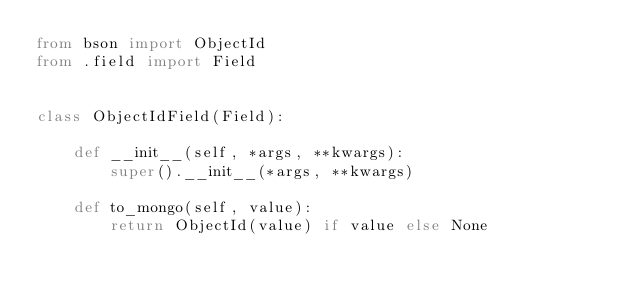<code> <loc_0><loc_0><loc_500><loc_500><_Python_>from bson import ObjectId
from .field import Field


class ObjectIdField(Field):

    def __init__(self, *args, **kwargs):
        super().__init__(*args, **kwargs)

    def to_mongo(self, value):
        return ObjectId(value) if value else None
</code> 